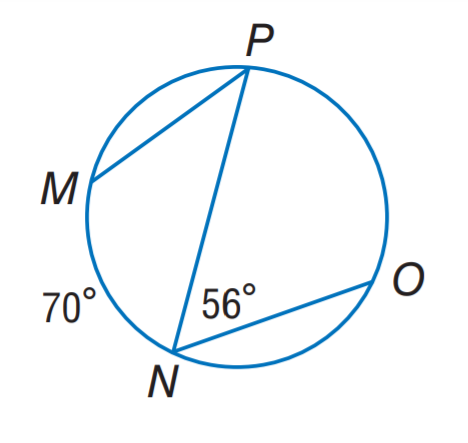Answer the mathemtical geometry problem and directly provide the correct option letter.
Question: Find m \angle P.
Choices: A: 28 B: 35 C: 56 D: 70 B 